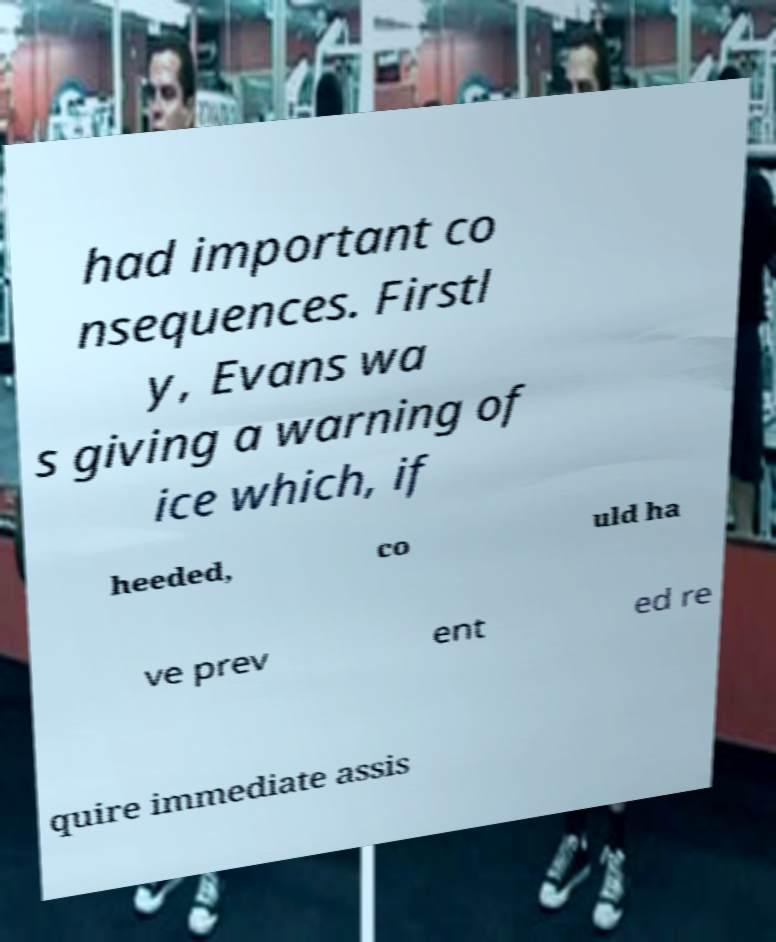What messages or text are displayed in this image? I need them in a readable, typed format. had important co nsequences. Firstl y, Evans wa s giving a warning of ice which, if heeded, co uld ha ve prev ent ed re quire immediate assis 